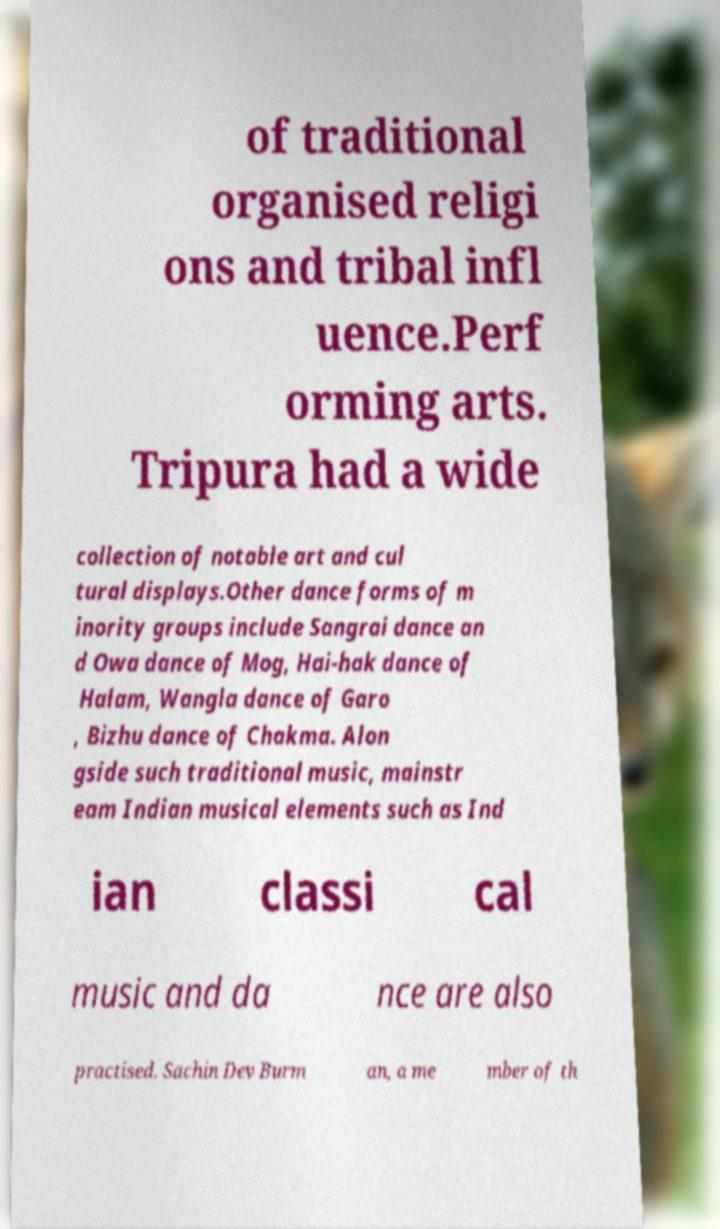I need the written content from this picture converted into text. Can you do that? of traditional organised religi ons and tribal infl uence.Perf orming arts. Tripura had a wide collection of notable art and cul tural displays.Other dance forms of m inority groups include Sangrai dance an d Owa dance of Mog, Hai-hak dance of Halam, Wangla dance of Garo , Bizhu dance of Chakma. Alon gside such traditional music, mainstr eam Indian musical elements such as Ind ian classi cal music and da nce are also practised. Sachin Dev Burm an, a me mber of th 